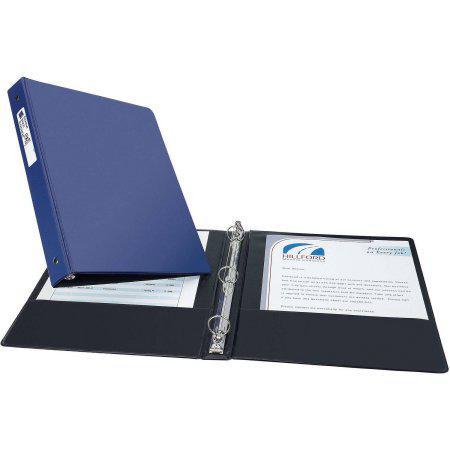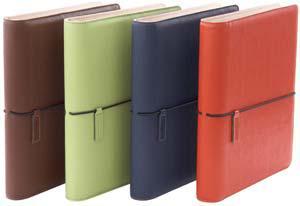The first image is the image on the left, the second image is the image on the right. For the images shown, is this caption "One image shows a binder both open and closed, while the other image shows a closed binder in two to four color options." true? Answer yes or no. Yes. The first image is the image on the left, the second image is the image on the right. Assess this claim about the two images: "One image shows a row of different colored binders.". Correct or not? Answer yes or no. Yes. 